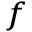<formula> <loc_0><loc_0><loc_500><loc_500>_ { f }</formula> 